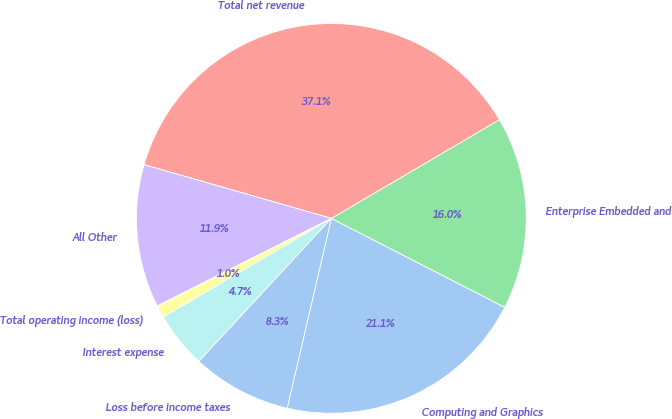<chart> <loc_0><loc_0><loc_500><loc_500><pie_chart><fcel>Computing and Graphics<fcel>Enterprise Embedded and<fcel>Total net revenue<fcel>All Other<fcel>Total operating income (loss)<fcel>Interest expense<fcel>Loss before income taxes<nl><fcel>21.1%<fcel>15.99%<fcel>37.1%<fcel>11.86%<fcel>1.04%<fcel>4.65%<fcel>8.25%<nl></chart> 